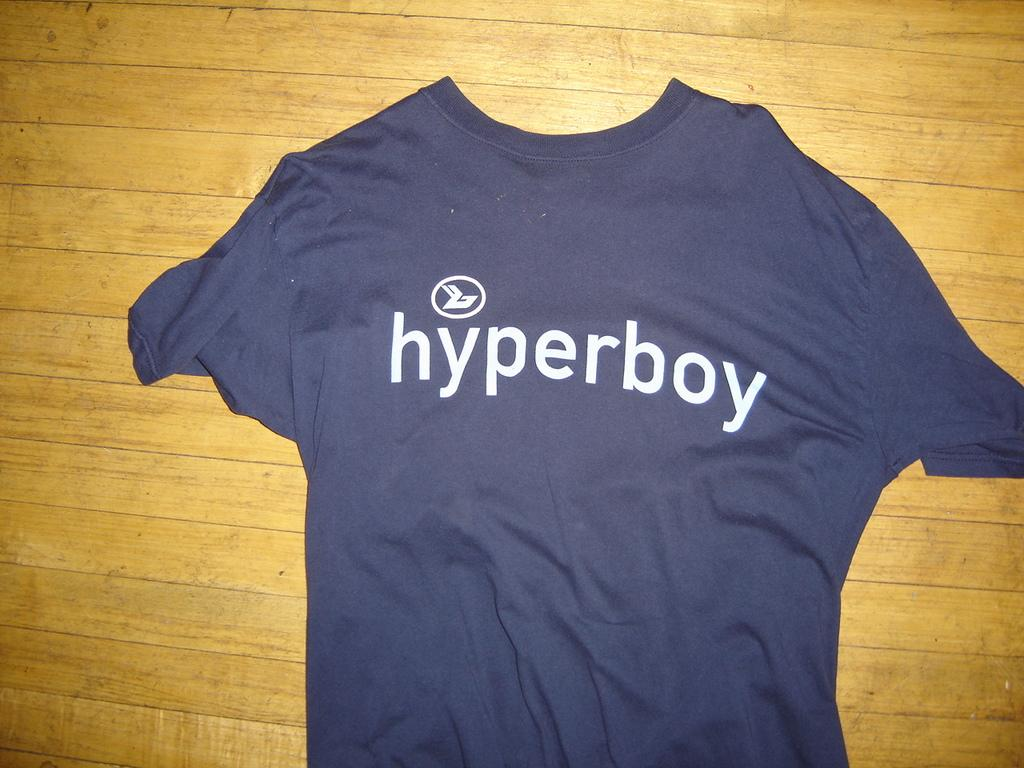<image>
Provide a brief description of the given image. A blue Hyperboy t-shirt is displayed on wooden background. 